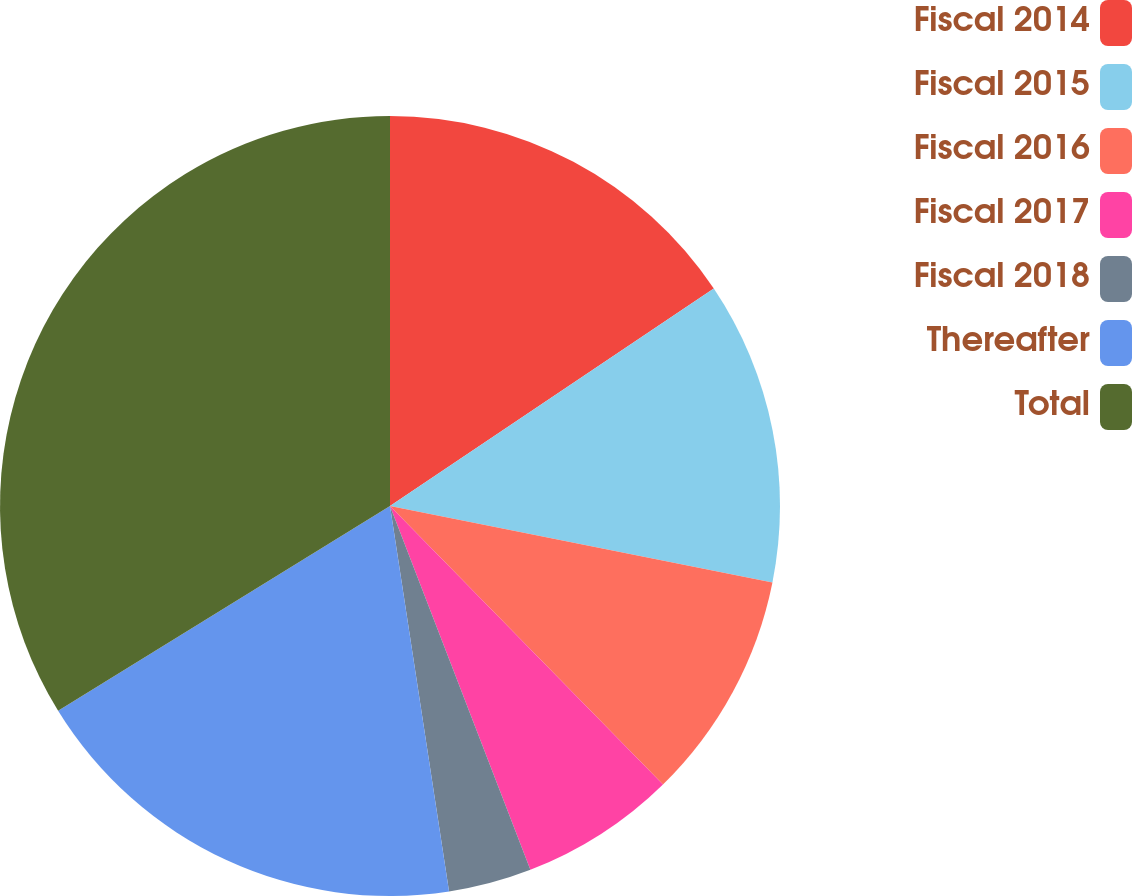<chart> <loc_0><loc_0><loc_500><loc_500><pie_chart><fcel>Fiscal 2014<fcel>Fiscal 2015<fcel>Fiscal 2016<fcel>Fiscal 2017<fcel>Fiscal 2018<fcel>Thereafter<fcel>Total<nl><fcel>15.59%<fcel>12.55%<fcel>9.52%<fcel>6.48%<fcel>3.44%<fcel>18.62%<fcel>33.8%<nl></chart> 